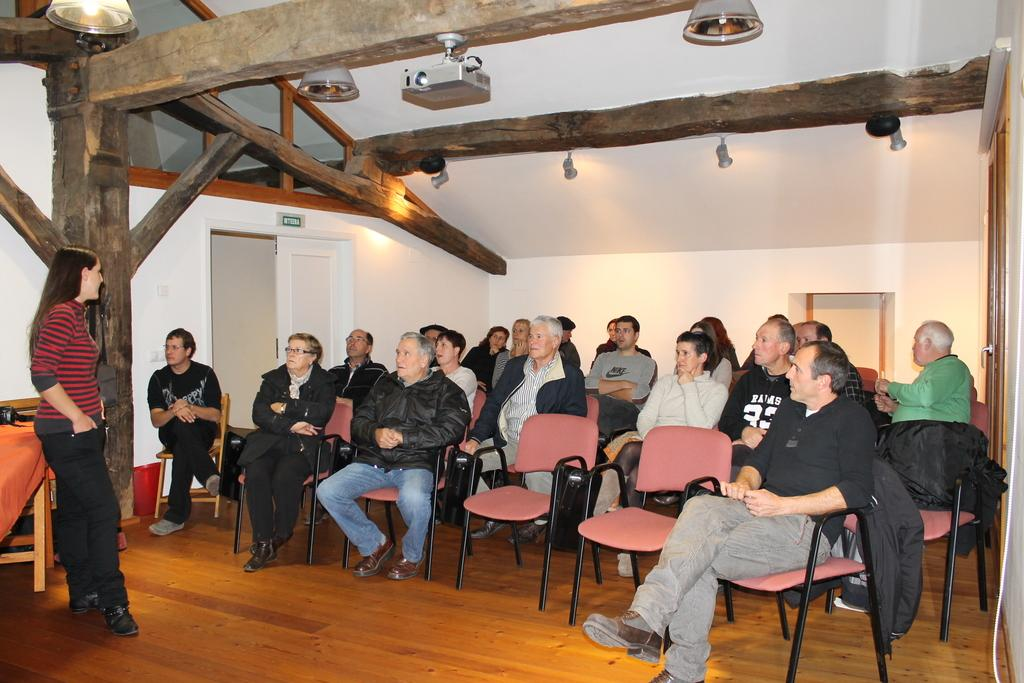What are the people in the image doing? There is a group of people sitting in the image. Can you describe the woman on the left side of the image? The woman is standing on the left side of the image. What is the floor made of in the image? The floor is made of wood. Where is the door located in the image? There is a door on the left side of the image. What device is present in the image for displaying visuals? There is a projector in the image. What type of lighting is present in the image? There are lights in the image. What type of comfort can be felt from the bedroom in the image? There is no bedroom present in the image; it features a group of people sitting and a woman standing. What taste can be experienced from the projector in the image? The projector is a device for displaying visuals and does not have a taste. 